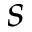<formula> <loc_0><loc_0><loc_500><loc_500>s</formula> 